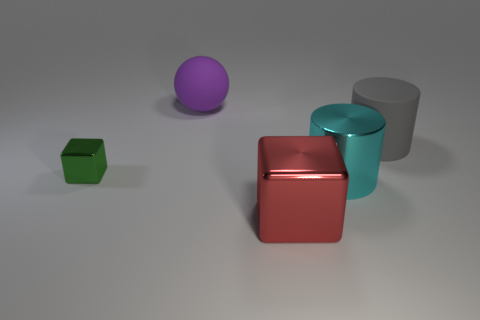There is a big cylinder that is in front of the matte thing on the right side of the rubber object to the left of the matte cylinder; what color is it?
Keep it short and to the point. Cyan. How many large things are in front of the big purple matte object and to the left of the large cyan metal cylinder?
Give a very brief answer. 1. What number of blocks are either green shiny things or cyan objects?
Give a very brief answer. 1. Are any large purple rubber balls visible?
Offer a terse response. Yes. What number of other objects are there of the same material as the gray cylinder?
Ensure brevity in your answer.  1. There is a cylinder that is the same size as the cyan thing; what is it made of?
Offer a terse response. Rubber. There is a large cyan shiny object that is right of the large red thing; does it have the same shape as the large red object?
Give a very brief answer. No. Do the tiny block and the ball have the same color?
Provide a short and direct response. No. What number of things are either things that are on the right side of the green block or big blue matte spheres?
Offer a terse response. 4. There is a gray rubber object that is the same size as the purple matte object; what is its shape?
Your answer should be very brief. Cylinder. 